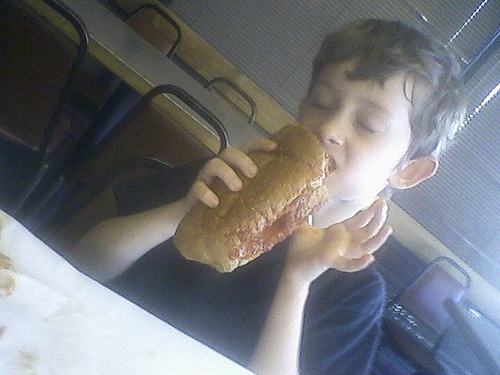Describe the objects in this image and their specific colors. I can see people in black, gray, darkgray, lightgray, and darkblue tones, dining table in black, lightgray, darkgray, and gray tones, chair in black and gray tones, sandwich in black, gray, tan, and olive tones, and chair in black and gray tones in this image. 